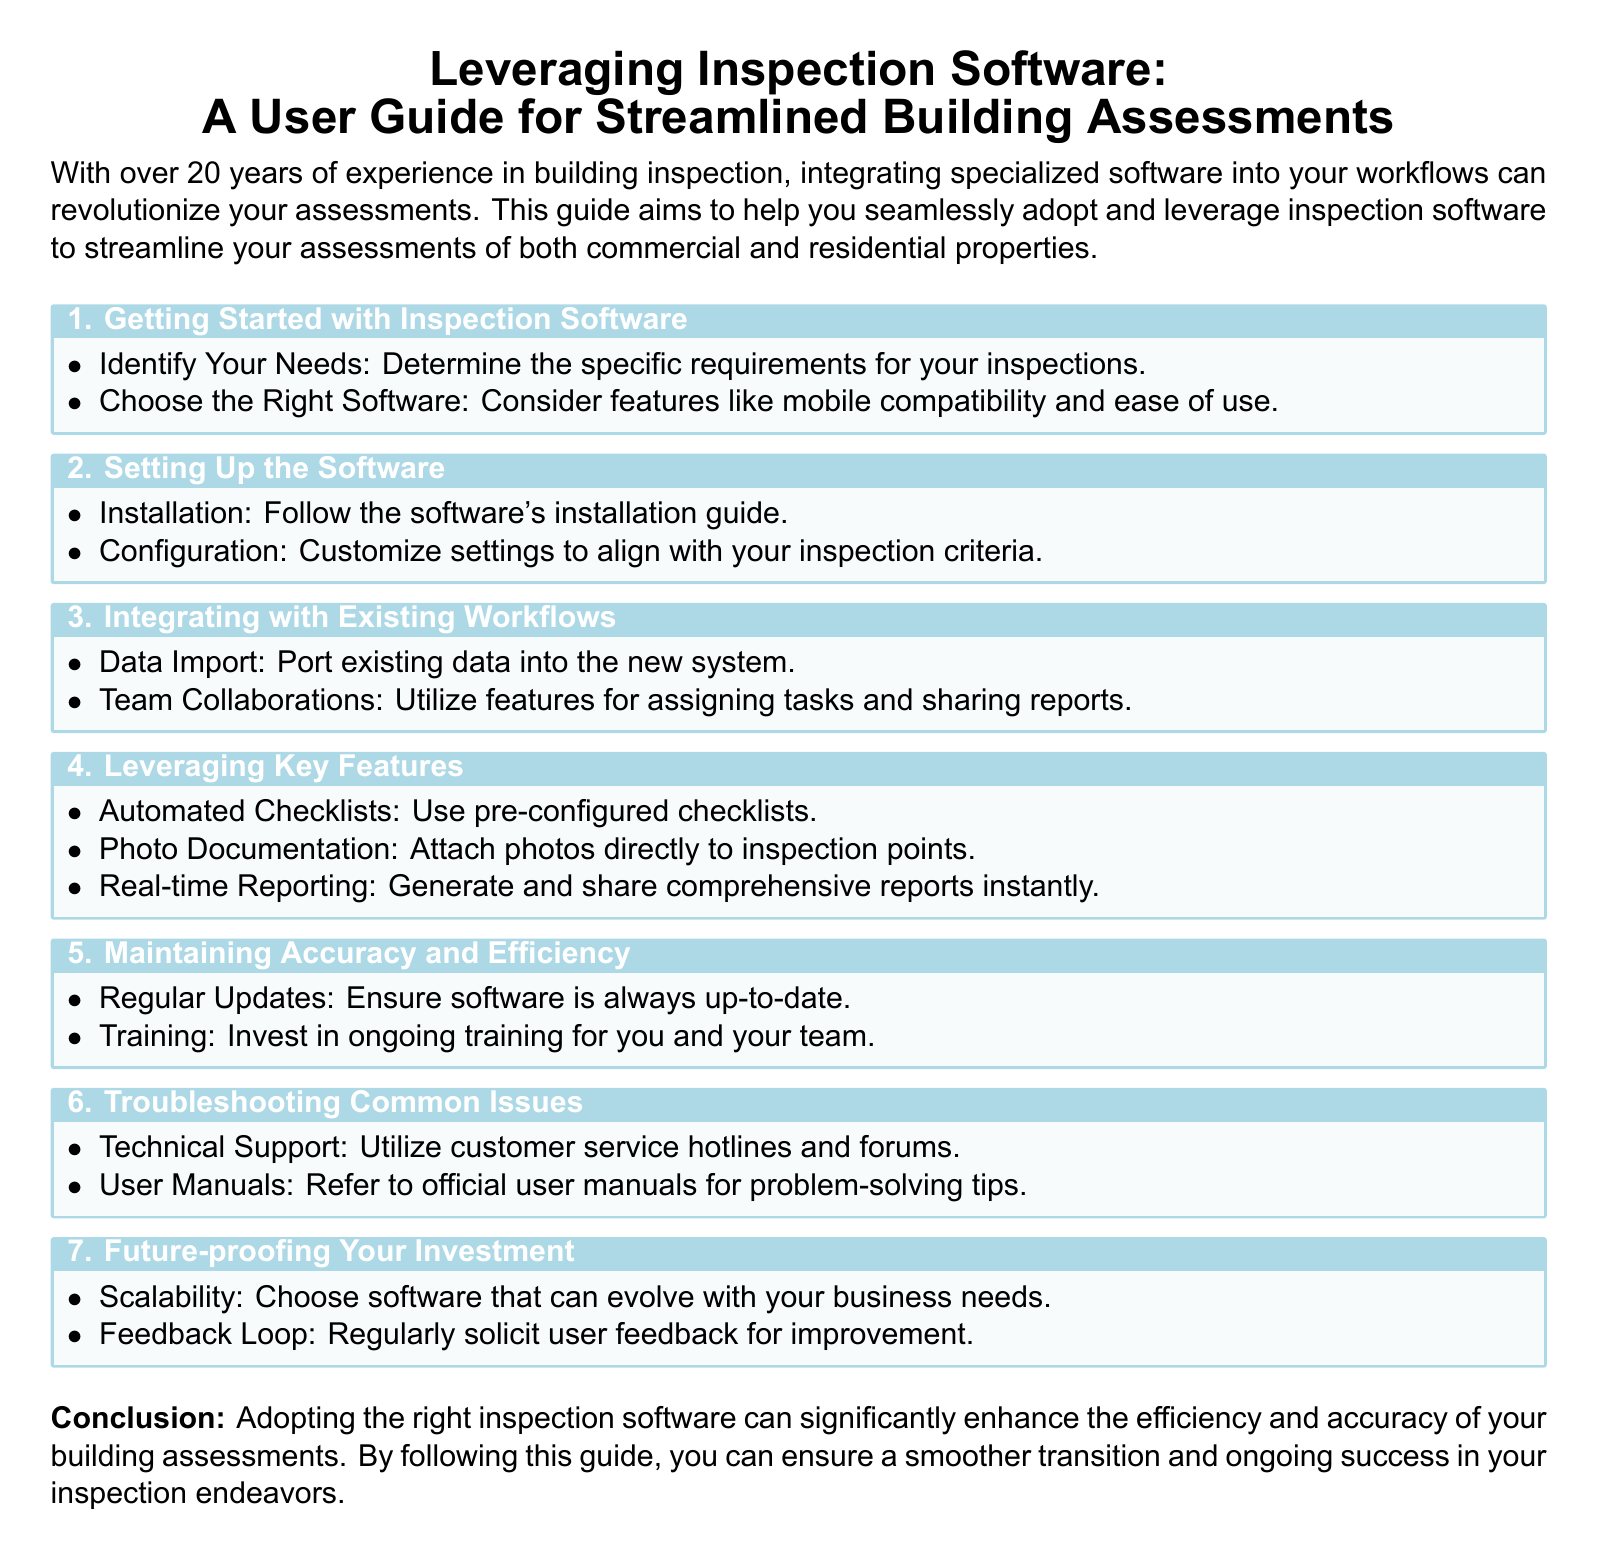What is the title of the document? The title appears prominently at the beginning of the document, which is "Leveraging Inspection Software: A User Guide for Streamlined Building Assessments."
Answer: Leveraging Inspection Software: A User Guide for Streamlined Building Assessments How many sections are in the guide? The guide contains seven distinct sections as numbered in the content.
Answer: 7 What feature allows users to attach photos during inspections? The document lists a specific feature related to photo documentation, which allows users to attach photos directly to inspection points.
Answer: Photo Documentation What is the importance of software updates according to the guide? The guide emphasizes the need for regular updates to ensure the software's effectiveness and accuracy.
Answer: Regular Updates Which topic addresses user support issues? The section dedicated to troubleshooting common problems specifically outlines user support options like technical support and user manuals.
Answer: Troubleshooting Common Issues 